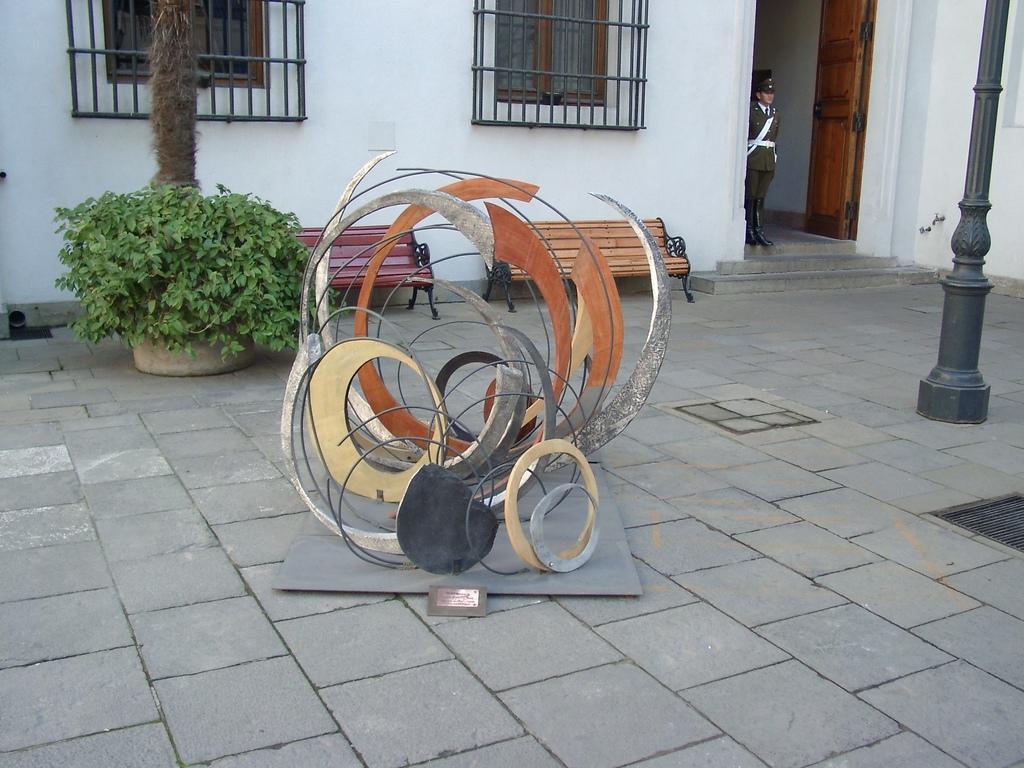Please provide a concise description of this image. In this image there is an object on the board , a person standing, pole, plant, a building with windows and a door, benches, iron grills. 